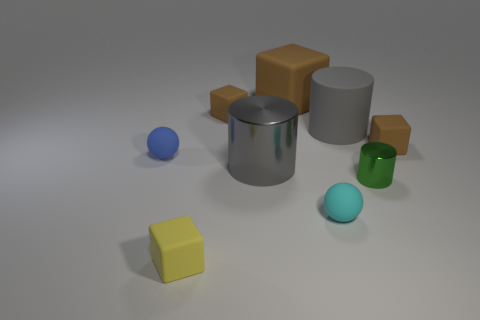There is another big cylinder that is the same color as the rubber cylinder; what is it made of?
Your response must be concise. Metal. Does the big shiny object have the same color as the large cylinder that is right of the large block?
Your answer should be compact. Yes. What shape is the tiny brown thing that is on the right side of the big cylinder in front of the brown rubber block that is right of the small green shiny thing?
Your answer should be very brief. Cube. How many other things are the same color as the big metal cylinder?
Ensure brevity in your answer.  1. Is the number of matte spheres to the right of the tiny blue rubber thing greater than the number of big matte objects that are behind the big brown rubber cube?
Offer a very short reply. Yes. There is a big metallic cylinder; are there any objects to the left of it?
Ensure brevity in your answer.  Yes. What material is the large thing that is both in front of the large brown thing and to the left of the large gray matte cylinder?
Provide a short and direct response. Metal. What is the color of the big rubber object that is the same shape as the green metal object?
Your answer should be very brief. Gray. Is there a tiny blue object behind the cube to the right of the large brown rubber object?
Ensure brevity in your answer.  No. What is the size of the green object?
Offer a very short reply. Small. 